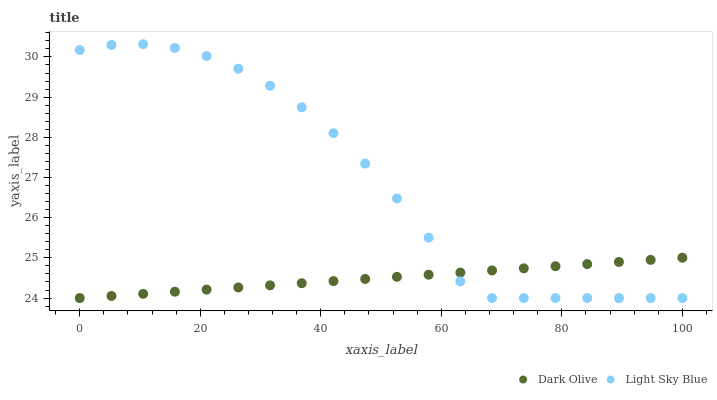Does Dark Olive have the minimum area under the curve?
Answer yes or no. Yes. Does Light Sky Blue have the maximum area under the curve?
Answer yes or no. Yes. Does Light Sky Blue have the minimum area under the curve?
Answer yes or no. No. Is Dark Olive the smoothest?
Answer yes or no. Yes. Is Light Sky Blue the roughest?
Answer yes or no. Yes. Is Light Sky Blue the smoothest?
Answer yes or no. No. Does Dark Olive have the lowest value?
Answer yes or no. Yes. Does Light Sky Blue have the highest value?
Answer yes or no. Yes. Does Dark Olive intersect Light Sky Blue?
Answer yes or no. Yes. Is Dark Olive less than Light Sky Blue?
Answer yes or no. No. Is Dark Olive greater than Light Sky Blue?
Answer yes or no. No. 